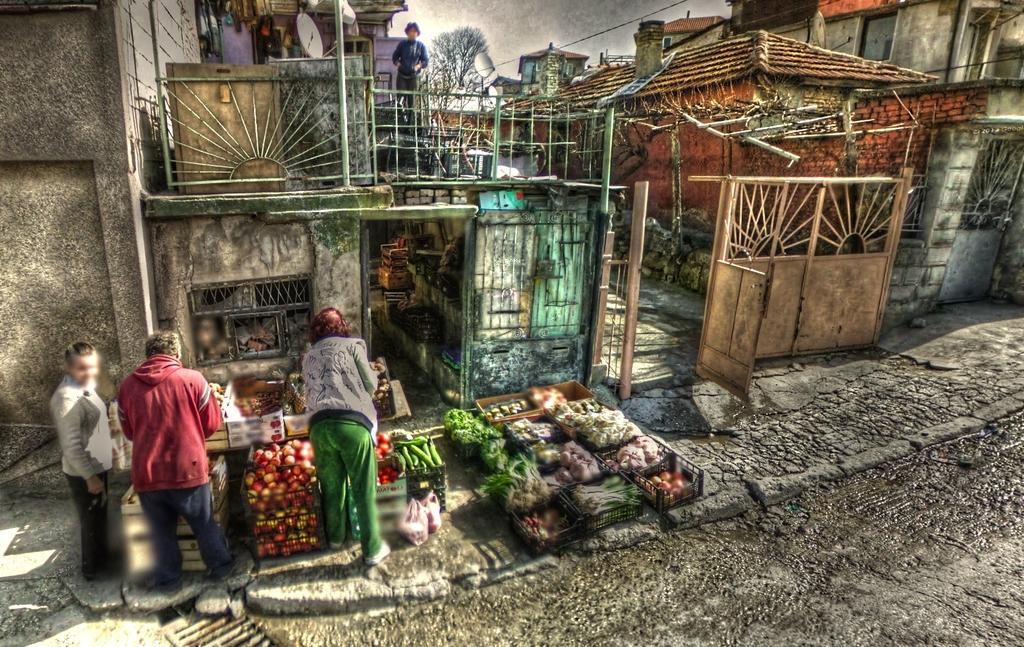What is happening in the center of the image? There are persons standing in the center of the image. What type of food items can be seen in the image? There are vegetables in the image. What can be seen in the distance in the image? There are houses and objects in the background of the image, as well as a tree. How would you describe the weather in the image? The sky is cloudy in the image. Can you see an owl perched on the tree in the background of the image? There is no owl present in the image; only the tree and other background elements can be seen. How many steps are visible in the image? There is no mention of steps in the image; the focus is on the persons, vegetables, and background elements. 